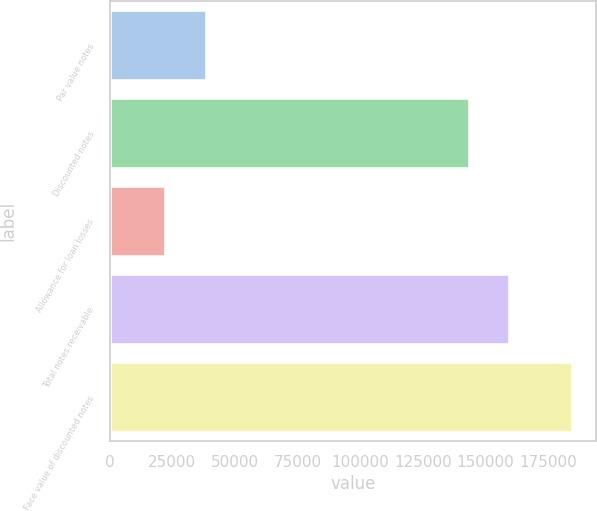Convert chart. <chart><loc_0><loc_0><loc_500><loc_500><bar_chart><fcel>Par value notes<fcel>Discounted notes<fcel>Allowance for loan losses<fcel>Total notes receivable<fcel>Face value of discounted notes<nl><fcel>38831.3<fcel>143698<fcel>22606<fcel>159923<fcel>184859<nl></chart> 